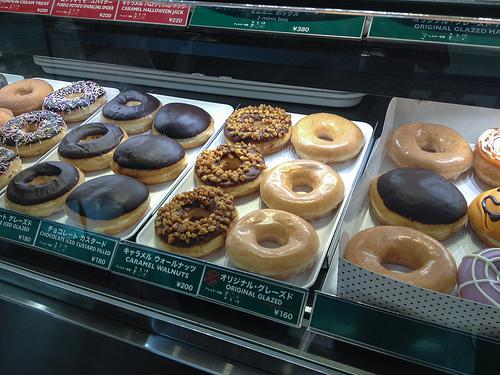Question: how many donuts are in each tray?
Choices:
A. 12.
B. Two.
C. 8.
D. Six.
Answer with the letter. Answer: D Question: why are the donuts on a shelf?
Choices:
A. To give away.
B. To display.
C. To eat.
D. To sell.
Answer with the letter. Answer: D Question: what kind of donuts are they?
Choices:
A. Assorted.
B. Jelly.
C. Creme filled.
D. Chocolate.
Answer with the letter. Answer: A Question: who made the donuts?
Choices:
A. Chef.
B. Baker.
C. Lady.
D. Kids.
Answer with the letter. Answer: B Question: where are the signs?
Choices:
A. On the road.
B. Highway.
C. Front of shelves.
D. Grass.
Answer with the letter. Answer: C 